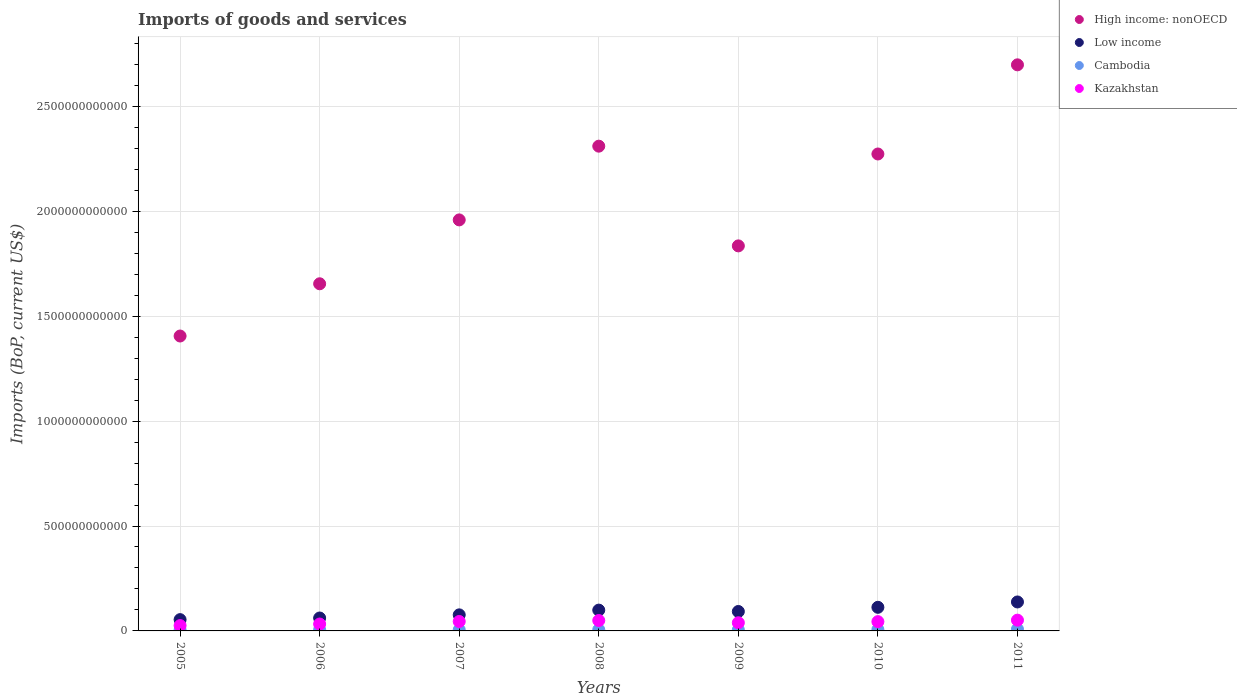What is the amount spent on imports in High income: nonOECD in 2009?
Provide a succinct answer. 1.83e+12. Across all years, what is the maximum amount spent on imports in Cambodia?
Give a very brief answer. 8.25e+09. Across all years, what is the minimum amount spent on imports in Cambodia?
Make the answer very short. 4.57e+09. What is the total amount spent on imports in Kazakhstan in the graph?
Provide a succinct answer. 2.87e+11. What is the difference between the amount spent on imports in Cambodia in 2008 and that in 2011?
Provide a succinct answer. -2.27e+09. What is the difference between the amount spent on imports in Kazakhstan in 2005 and the amount spent on imports in Cambodia in 2010?
Offer a terse response. 1.90e+1. What is the average amount spent on imports in Kazakhstan per year?
Keep it short and to the point. 4.11e+1. In the year 2007, what is the difference between the amount spent on imports in Kazakhstan and amount spent on imports in Low income?
Give a very brief answer. -3.16e+1. What is the ratio of the amount spent on imports in High income: nonOECD in 2006 to that in 2009?
Make the answer very short. 0.9. Is the difference between the amount spent on imports in Kazakhstan in 2007 and 2010 greater than the difference between the amount spent on imports in Low income in 2007 and 2010?
Offer a terse response. Yes. What is the difference between the highest and the second highest amount spent on imports in Low income?
Offer a terse response. 2.55e+1. What is the difference between the highest and the lowest amount spent on imports in Kazakhstan?
Ensure brevity in your answer.  2.59e+1. In how many years, is the amount spent on imports in High income: nonOECD greater than the average amount spent on imports in High income: nonOECD taken over all years?
Give a very brief answer. 3. Is the sum of the amount spent on imports in High income: nonOECD in 2007 and 2009 greater than the maximum amount spent on imports in Kazakhstan across all years?
Offer a very short reply. Yes. Is it the case that in every year, the sum of the amount spent on imports in Cambodia and amount spent on imports in Low income  is greater than the sum of amount spent on imports in Kazakhstan and amount spent on imports in High income: nonOECD?
Offer a very short reply. No. Is the amount spent on imports in High income: nonOECD strictly greater than the amount spent on imports in Cambodia over the years?
Offer a terse response. Yes. What is the difference between two consecutive major ticks on the Y-axis?
Provide a succinct answer. 5.00e+11. Does the graph contain grids?
Ensure brevity in your answer.  Yes. Where does the legend appear in the graph?
Provide a succinct answer. Top right. How many legend labels are there?
Your answer should be compact. 4. What is the title of the graph?
Your answer should be compact. Imports of goods and services. Does "Portugal" appear as one of the legend labels in the graph?
Your answer should be compact. No. What is the label or title of the Y-axis?
Your answer should be very brief. Imports (BoP, current US$). What is the Imports (BoP, current US$) in High income: nonOECD in 2005?
Provide a succinct answer. 1.41e+12. What is the Imports (BoP, current US$) of Low income in 2005?
Make the answer very short. 5.38e+1. What is the Imports (BoP, current US$) of Cambodia in 2005?
Provide a short and direct response. 4.57e+09. What is the Imports (BoP, current US$) in Kazakhstan in 2005?
Make the answer very short. 2.55e+1. What is the Imports (BoP, current US$) in High income: nonOECD in 2006?
Offer a very short reply. 1.65e+12. What is the Imports (BoP, current US$) of Low income in 2006?
Your answer should be compact. 6.15e+1. What is the Imports (BoP, current US$) of Cambodia in 2006?
Keep it short and to the point. 5.58e+09. What is the Imports (BoP, current US$) in Kazakhstan in 2006?
Your answer should be very brief. 3.29e+1. What is the Imports (BoP, current US$) in High income: nonOECD in 2007?
Offer a very short reply. 1.96e+12. What is the Imports (BoP, current US$) of Low income in 2007?
Your answer should be very brief. 7.65e+1. What is the Imports (BoP, current US$) of Cambodia in 2007?
Offer a very short reply. 5.34e+09. What is the Imports (BoP, current US$) in Kazakhstan in 2007?
Offer a very short reply. 4.50e+1. What is the Imports (BoP, current US$) in High income: nonOECD in 2008?
Provide a succinct answer. 2.31e+12. What is the Imports (BoP, current US$) in Low income in 2008?
Keep it short and to the point. 9.92e+1. What is the Imports (BoP, current US$) in Cambodia in 2008?
Your response must be concise. 5.98e+09. What is the Imports (BoP, current US$) in Kazakhstan in 2008?
Keep it short and to the point. 4.96e+1. What is the Imports (BoP, current US$) of High income: nonOECD in 2009?
Make the answer very short. 1.83e+12. What is the Imports (BoP, current US$) of Low income in 2009?
Provide a short and direct response. 9.26e+1. What is the Imports (BoP, current US$) of Cambodia in 2009?
Provide a short and direct response. 5.46e+09. What is the Imports (BoP, current US$) of Kazakhstan in 2009?
Provide a succinct answer. 3.90e+1. What is the Imports (BoP, current US$) of High income: nonOECD in 2010?
Provide a short and direct response. 2.27e+12. What is the Imports (BoP, current US$) in Low income in 2010?
Ensure brevity in your answer.  1.13e+11. What is the Imports (BoP, current US$) of Cambodia in 2010?
Make the answer very short. 6.47e+09. What is the Imports (BoP, current US$) of Kazakhstan in 2010?
Your answer should be very brief. 4.43e+1. What is the Imports (BoP, current US$) of High income: nonOECD in 2011?
Provide a short and direct response. 2.70e+12. What is the Imports (BoP, current US$) of Low income in 2011?
Make the answer very short. 1.38e+11. What is the Imports (BoP, current US$) in Cambodia in 2011?
Make the answer very short. 8.25e+09. What is the Imports (BoP, current US$) of Kazakhstan in 2011?
Provide a short and direct response. 5.13e+1. Across all years, what is the maximum Imports (BoP, current US$) of High income: nonOECD?
Ensure brevity in your answer.  2.70e+12. Across all years, what is the maximum Imports (BoP, current US$) in Low income?
Provide a short and direct response. 1.38e+11. Across all years, what is the maximum Imports (BoP, current US$) in Cambodia?
Offer a very short reply. 8.25e+09. Across all years, what is the maximum Imports (BoP, current US$) of Kazakhstan?
Offer a very short reply. 5.13e+1. Across all years, what is the minimum Imports (BoP, current US$) in High income: nonOECD?
Your answer should be compact. 1.41e+12. Across all years, what is the minimum Imports (BoP, current US$) of Low income?
Provide a short and direct response. 5.38e+1. Across all years, what is the minimum Imports (BoP, current US$) in Cambodia?
Your answer should be very brief. 4.57e+09. Across all years, what is the minimum Imports (BoP, current US$) in Kazakhstan?
Give a very brief answer. 2.55e+1. What is the total Imports (BoP, current US$) in High income: nonOECD in the graph?
Keep it short and to the point. 1.41e+13. What is the total Imports (BoP, current US$) in Low income in the graph?
Offer a very short reply. 6.34e+11. What is the total Imports (BoP, current US$) in Cambodia in the graph?
Offer a terse response. 4.16e+1. What is the total Imports (BoP, current US$) of Kazakhstan in the graph?
Provide a short and direct response. 2.87e+11. What is the difference between the Imports (BoP, current US$) of High income: nonOECD in 2005 and that in 2006?
Ensure brevity in your answer.  -2.49e+11. What is the difference between the Imports (BoP, current US$) in Low income in 2005 and that in 2006?
Your answer should be compact. -7.70e+09. What is the difference between the Imports (BoP, current US$) in Cambodia in 2005 and that in 2006?
Provide a short and direct response. -1.01e+09. What is the difference between the Imports (BoP, current US$) of Kazakhstan in 2005 and that in 2006?
Your response must be concise. -7.42e+09. What is the difference between the Imports (BoP, current US$) of High income: nonOECD in 2005 and that in 2007?
Make the answer very short. -5.53e+11. What is the difference between the Imports (BoP, current US$) in Low income in 2005 and that in 2007?
Ensure brevity in your answer.  -2.27e+1. What is the difference between the Imports (BoP, current US$) in Cambodia in 2005 and that in 2007?
Your answer should be compact. -7.61e+08. What is the difference between the Imports (BoP, current US$) of Kazakhstan in 2005 and that in 2007?
Your response must be concise. -1.95e+1. What is the difference between the Imports (BoP, current US$) of High income: nonOECD in 2005 and that in 2008?
Your answer should be very brief. -9.05e+11. What is the difference between the Imports (BoP, current US$) of Low income in 2005 and that in 2008?
Your answer should be compact. -4.53e+1. What is the difference between the Imports (BoP, current US$) in Cambodia in 2005 and that in 2008?
Your response must be concise. -1.40e+09. What is the difference between the Imports (BoP, current US$) of Kazakhstan in 2005 and that in 2008?
Make the answer very short. -2.41e+1. What is the difference between the Imports (BoP, current US$) of High income: nonOECD in 2005 and that in 2009?
Make the answer very short. -4.30e+11. What is the difference between the Imports (BoP, current US$) of Low income in 2005 and that in 2009?
Offer a terse response. -3.88e+1. What is the difference between the Imports (BoP, current US$) in Cambodia in 2005 and that in 2009?
Provide a succinct answer. -8.81e+08. What is the difference between the Imports (BoP, current US$) in Kazakhstan in 2005 and that in 2009?
Provide a short and direct response. -1.35e+1. What is the difference between the Imports (BoP, current US$) of High income: nonOECD in 2005 and that in 2010?
Keep it short and to the point. -8.68e+11. What is the difference between the Imports (BoP, current US$) in Low income in 2005 and that in 2010?
Offer a terse response. -5.87e+1. What is the difference between the Imports (BoP, current US$) of Cambodia in 2005 and that in 2010?
Your answer should be compact. -1.90e+09. What is the difference between the Imports (BoP, current US$) in Kazakhstan in 2005 and that in 2010?
Ensure brevity in your answer.  -1.88e+1. What is the difference between the Imports (BoP, current US$) of High income: nonOECD in 2005 and that in 2011?
Your answer should be very brief. -1.29e+12. What is the difference between the Imports (BoP, current US$) of Low income in 2005 and that in 2011?
Make the answer very short. -8.42e+1. What is the difference between the Imports (BoP, current US$) of Cambodia in 2005 and that in 2011?
Provide a succinct answer. -3.68e+09. What is the difference between the Imports (BoP, current US$) of Kazakhstan in 2005 and that in 2011?
Provide a succinct answer. -2.59e+1. What is the difference between the Imports (BoP, current US$) in High income: nonOECD in 2006 and that in 2007?
Your answer should be very brief. -3.04e+11. What is the difference between the Imports (BoP, current US$) in Low income in 2006 and that in 2007?
Your answer should be very brief. -1.50e+1. What is the difference between the Imports (BoP, current US$) in Cambodia in 2006 and that in 2007?
Your response must be concise. 2.46e+08. What is the difference between the Imports (BoP, current US$) of Kazakhstan in 2006 and that in 2007?
Provide a short and direct response. -1.21e+1. What is the difference between the Imports (BoP, current US$) in High income: nonOECD in 2006 and that in 2008?
Offer a very short reply. -6.56e+11. What is the difference between the Imports (BoP, current US$) in Low income in 2006 and that in 2008?
Give a very brief answer. -3.76e+1. What is the difference between the Imports (BoP, current US$) in Cambodia in 2006 and that in 2008?
Offer a very short reply. -3.96e+08. What is the difference between the Imports (BoP, current US$) in Kazakhstan in 2006 and that in 2008?
Provide a succinct answer. -1.67e+1. What is the difference between the Imports (BoP, current US$) in High income: nonOECD in 2006 and that in 2009?
Offer a very short reply. -1.81e+11. What is the difference between the Imports (BoP, current US$) of Low income in 2006 and that in 2009?
Ensure brevity in your answer.  -3.11e+1. What is the difference between the Imports (BoP, current US$) in Cambodia in 2006 and that in 2009?
Make the answer very short. 1.26e+08. What is the difference between the Imports (BoP, current US$) in Kazakhstan in 2006 and that in 2009?
Offer a very short reply. -6.12e+09. What is the difference between the Imports (BoP, current US$) of High income: nonOECD in 2006 and that in 2010?
Your answer should be compact. -6.19e+11. What is the difference between the Imports (BoP, current US$) in Low income in 2006 and that in 2010?
Provide a short and direct response. -5.10e+1. What is the difference between the Imports (BoP, current US$) in Cambodia in 2006 and that in 2010?
Keep it short and to the point. -8.91e+08. What is the difference between the Imports (BoP, current US$) in Kazakhstan in 2006 and that in 2010?
Keep it short and to the point. -1.14e+1. What is the difference between the Imports (BoP, current US$) in High income: nonOECD in 2006 and that in 2011?
Your response must be concise. -1.04e+12. What is the difference between the Imports (BoP, current US$) of Low income in 2006 and that in 2011?
Make the answer very short. -7.65e+1. What is the difference between the Imports (BoP, current US$) of Cambodia in 2006 and that in 2011?
Ensure brevity in your answer.  -2.67e+09. What is the difference between the Imports (BoP, current US$) in Kazakhstan in 2006 and that in 2011?
Give a very brief answer. -1.84e+1. What is the difference between the Imports (BoP, current US$) in High income: nonOECD in 2007 and that in 2008?
Your response must be concise. -3.51e+11. What is the difference between the Imports (BoP, current US$) of Low income in 2007 and that in 2008?
Provide a short and direct response. -2.26e+1. What is the difference between the Imports (BoP, current US$) in Cambodia in 2007 and that in 2008?
Your response must be concise. -6.42e+08. What is the difference between the Imports (BoP, current US$) of Kazakhstan in 2007 and that in 2008?
Provide a short and direct response. -4.58e+09. What is the difference between the Imports (BoP, current US$) in High income: nonOECD in 2007 and that in 2009?
Your answer should be compact. 1.24e+11. What is the difference between the Imports (BoP, current US$) of Low income in 2007 and that in 2009?
Your response must be concise. -1.61e+1. What is the difference between the Imports (BoP, current US$) in Cambodia in 2007 and that in 2009?
Keep it short and to the point. -1.20e+08. What is the difference between the Imports (BoP, current US$) of Kazakhstan in 2007 and that in 2009?
Your answer should be very brief. 5.99e+09. What is the difference between the Imports (BoP, current US$) of High income: nonOECD in 2007 and that in 2010?
Offer a very short reply. -3.14e+11. What is the difference between the Imports (BoP, current US$) of Low income in 2007 and that in 2010?
Your answer should be very brief. -3.60e+1. What is the difference between the Imports (BoP, current US$) of Cambodia in 2007 and that in 2010?
Provide a short and direct response. -1.14e+09. What is the difference between the Imports (BoP, current US$) in Kazakhstan in 2007 and that in 2010?
Your response must be concise. 7.30e+08. What is the difference between the Imports (BoP, current US$) in High income: nonOECD in 2007 and that in 2011?
Keep it short and to the point. -7.39e+11. What is the difference between the Imports (BoP, current US$) in Low income in 2007 and that in 2011?
Offer a very short reply. -6.15e+1. What is the difference between the Imports (BoP, current US$) in Cambodia in 2007 and that in 2011?
Give a very brief answer. -2.92e+09. What is the difference between the Imports (BoP, current US$) in Kazakhstan in 2007 and that in 2011?
Your answer should be compact. -6.33e+09. What is the difference between the Imports (BoP, current US$) of High income: nonOECD in 2008 and that in 2009?
Your answer should be very brief. 4.75e+11. What is the difference between the Imports (BoP, current US$) in Low income in 2008 and that in 2009?
Provide a succinct answer. 6.54e+09. What is the difference between the Imports (BoP, current US$) of Cambodia in 2008 and that in 2009?
Provide a short and direct response. 5.22e+08. What is the difference between the Imports (BoP, current US$) in Kazakhstan in 2008 and that in 2009?
Make the answer very short. 1.06e+1. What is the difference between the Imports (BoP, current US$) of High income: nonOECD in 2008 and that in 2010?
Provide a succinct answer. 3.72e+1. What is the difference between the Imports (BoP, current US$) of Low income in 2008 and that in 2010?
Give a very brief answer. -1.34e+1. What is the difference between the Imports (BoP, current US$) of Cambodia in 2008 and that in 2010?
Provide a short and direct response. -4.95e+08. What is the difference between the Imports (BoP, current US$) of Kazakhstan in 2008 and that in 2010?
Provide a succinct answer. 5.31e+09. What is the difference between the Imports (BoP, current US$) of High income: nonOECD in 2008 and that in 2011?
Your answer should be very brief. -3.88e+11. What is the difference between the Imports (BoP, current US$) in Low income in 2008 and that in 2011?
Provide a short and direct response. -3.89e+1. What is the difference between the Imports (BoP, current US$) in Cambodia in 2008 and that in 2011?
Provide a short and direct response. -2.27e+09. What is the difference between the Imports (BoP, current US$) in Kazakhstan in 2008 and that in 2011?
Offer a terse response. -1.75e+09. What is the difference between the Imports (BoP, current US$) in High income: nonOECD in 2009 and that in 2010?
Your response must be concise. -4.38e+11. What is the difference between the Imports (BoP, current US$) of Low income in 2009 and that in 2010?
Your answer should be compact. -1.99e+1. What is the difference between the Imports (BoP, current US$) in Cambodia in 2009 and that in 2010?
Provide a succinct answer. -1.02e+09. What is the difference between the Imports (BoP, current US$) in Kazakhstan in 2009 and that in 2010?
Your answer should be very brief. -5.26e+09. What is the difference between the Imports (BoP, current US$) of High income: nonOECD in 2009 and that in 2011?
Make the answer very short. -8.63e+11. What is the difference between the Imports (BoP, current US$) of Low income in 2009 and that in 2011?
Ensure brevity in your answer.  -4.54e+1. What is the difference between the Imports (BoP, current US$) in Cambodia in 2009 and that in 2011?
Your response must be concise. -2.80e+09. What is the difference between the Imports (BoP, current US$) in Kazakhstan in 2009 and that in 2011?
Ensure brevity in your answer.  -1.23e+1. What is the difference between the Imports (BoP, current US$) of High income: nonOECD in 2010 and that in 2011?
Keep it short and to the point. -4.25e+11. What is the difference between the Imports (BoP, current US$) of Low income in 2010 and that in 2011?
Your answer should be very brief. -2.55e+1. What is the difference between the Imports (BoP, current US$) of Cambodia in 2010 and that in 2011?
Make the answer very short. -1.78e+09. What is the difference between the Imports (BoP, current US$) of Kazakhstan in 2010 and that in 2011?
Ensure brevity in your answer.  -7.06e+09. What is the difference between the Imports (BoP, current US$) in High income: nonOECD in 2005 and the Imports (BoP, current US$) in Low income in 2006?
Your answer should be very brief. 1.34e+12. What is the difference between the Imports (BoP, current US$) of High income: nonOECD in 2005 and the Imports (BoP, current US$) of Cambodia in 2006?
Make the answer very short. 1.40e+12. What is the difference between the Imports (BoP, current US$) of High income: nonOECD in 2005 and the Imports (BoP, current US$) of Kazakhstan in 2006?
Keep it short and to the point. 1.37e+12. What is the difference between the Imports (BoP, current US$) in Low income in 2005 and the Imports (BoP, current US$) in Cambodia in 2006?
Give a very brief answer. 4.83e+1. What is the difference between the Imports (BoP, current US$) of Low income in 2005 and the Imports (BoP, current US$) of Kazakhstan in 2006?
Make the answer very short. 2.10e+1. What is the difference between the Imports (BoP, current US$) of Cambodia in 2005 and the Imports (BoP, current US$) of Kazakhstan in 2006?
Ensure brevity in your answer.  -2.83e+1. What is the difference between the Imports (BoP, current US$) of High income: nonOECD in 2005 and the Imports (BoP, current US$) of Low income in 2007?
Ensure brevity in your answer.  1.33e+12. What is the difference between the Imports (BoP, current US$) in High income: nonOECD in 2005 and the Imports (BoP, current US$) in Cambodia in 2007?
Offer a terse response. 1.40e+12. What is the difference between the Imports (BoP, current US$) in High income: nonOECD in 2005 and the Imports (BoP, current US$) in Kazakhstan in 2007?
Your answer should be compact. 1.36e+12. What is the difference between the Imports (BoP, current US$) in Low income in 2005 and the Imports (BoP, current US$) in Cambodia in 2007?
Your answer should be compact. 4.85e+1. What is the difference between the Imports (BoP, current US$) in Low income in 2005 and the Imports (BoP, current US$) in Kazakhstan in 2007?
Offer a terse response. 8.85e+09. What is the difference between the Imports (BoP, current US$) in Cambodia in 2005 and the Imports (BoP, current US$) in Kazakhstan in 2007?
Provide a succinct answer. -4.04e+1. What is the difference between the Imports (BoP, current US$) in High income: nonOECD in 2005 and the Imports (BoP, current US$) in Low income in 2008?
Your response must be concise. 1.31e+12. What is the difference between the Imports (BoP, current US$) in High income: nonOECD in 2005 and the Imports (BoP, current US$) in Cambodia in 2008?
Your answer should be very brief. 1.40e+12. What is the difference between the Imports (BoP, current US$) in High income: nonOECD in 2005 and the Imports (BoP, current US$) in Kazakhstan in 2008?
Your response must be concise. 1.36e+12. What is the difference between the Imports (BoP, current US$) of Low income in 2005 and the Imports (BoP, current US$) of Cambodia in 2008?
Keep it short and to the point. 4.79e+1. What is the difference between the Imports (BoP, current US$) of Low income in 2005 and the Imports (BoP, current US$) of Kazakhstan in 2008?
Provide a succinct answer. 4.27e+09. What is the difference between the Imports (BoP, current US$) of Cambodia in 2005 and the Imports (BoP, current US$) of Kazakhstan in 2008?
Ensure brevity in your answer.  -4.50e+1. What is the difference between the Imports (BoP, current US$) of High income: nonOECD in 2005 and the Imports (BoP, current US$) of Low income in 2009?
Ensure brevity in your answer.  1.31e+12. What is the difference between the Imports (BoP, current US$) of High income: nonOECD in 2005 and the Imports (BoP, current US$) of Cambodia in 2009?
Give a very brief answer. 1.40e+12. What is the difference between the Imports (BoP, current US$) of High income: nonOECD in 2005 and the Imports (BoP, current US$) of Kazakhstan in 2009?
Offer a terse response. 1.37e+12. What is the difference between the Imports (BoP, current US$) of Low income in 2005 and the Imports (BoP, current US$) of Cambodia in 2009?
Give a very brief answer. 4.84e+1. What is the difference between the Imports (BoP, current US$) in Low income in 2005 and the Imports (BoP, current US$) in Kazakhstan in 2009?
Your answer should be compact. 1.48e+1. What is the difference between the Imports (BoP, current US$) in Cambodia in 2005 and the Imports (BoP, current US$) in Kazakhstan in 2009?
Keep it short and to the point. -3.44e+1. What is the difference between the Imports (BoP, current US$) in High income: nonOECD in 2005 and the Imports (BoP, current US$) in Low income in 2010?
Ensure brevity in your answer.  1.29e+12. What is the difference between the Imports (BoP, current US$) of High income: nonOECD in 2005 and the Imports (BoP, current US$) of Cambodia in 2010?
Your answer should be compact. 1.40e+12. What is the difference between the Imports (BoP, current US$) in High income: nonOECD in 2005 and the Imports (BoP, current US$) in Kazakhstan in 2010?
Make the answer very short. 1.36e+12. What is the difference between the Imports (BoP, current US$) in Low income in 2005 and the Imports (BoP, current US$) in Cambodia in 2010?
Your answer should be very brief. 4.74e+1. What is the difference between the Imports (BoP, current US$) of Low income in 2005 and the Imports (BoP, current US$) of Kazakhstan in 2010?
Offer a very short reply. 9.58e+09. What is the difference between the Imports (BoP, current US$) of Cambodia in 2005 and the Imports (BoP, current US$) of Kazakhstan in 2010?
Give a very brief answer. -3.97e+1. What is the difference between the Imports (BoP, current US$) in High income: nonOECD in 2005 and the Imports (BoP, current US$) in Low income in 2011?
Your answer should be compact. 1.27e+12. What is the difference between the Imports (BoP, current US$) of High income: nonOECD in 2005 and the Imports (BoP, current US$) of Cambodia in 2011?
Keep it short and to the point. 1.40e+12. What is the difference between the Imports (BoP, current US$) of High income: nonOECD in 2005 and the Imports (BoP, current US$) of Kazakhstan in 2011?
Your answer should be compact. 1.35e+12. What is the difference between the Imports (BoP, current US$) in Low income in 2005 and the Imports (BoP, current US$) in Cambodia in 2011?
Offer a terse response. 4.56e+1. What is the difference between the Imports (BoP, current US$) of Low income in 2005 and the Imports (BoP, current US$) of Kazakhstan in 2011?
Your answer should be very brief. 2.52e+09. What is the difference between the Imports (BoP, current US$) of Cambodia in 2005 and the Imports (BoP, current US$) of Kazakhstan in 2011?
Give a very brief answer. -4.67e+1. What is the difference between the Imports (BoP, current US$) in High income: nonOECD in 2006 and the Imports (BoP, current US$) in Low income in 2007?
Your answer should be compact. 1.58e+12. What is the difference between the Imports (BoP, current US$) in High income: nonOECD in 2006 and the Imports (BoP, current US$) in Cambodia in 2007?
Give a very brief answer. 1.65e+12. What is the difference between the Imports (BoP, current US$) in High income: nonOECD in 2006 and the Imports (BoP, current US$) in Kazakhstan in 2007?
Your answer should be compact. 1.61e+12. What is the difference between the Imports (BoP, current US$) in Low income in 2006 and the Imports (BoP, current US$) in Cambodia in 2007?
Make the answer very short. 5.62e+1. What is the difference between the Imports (BoP, current US$) in Low income in 2006 and the Imports (BoP, current US$) in Kazakhstan in 2007?
Provide a succinct answer. 1.66e+1. What is the difference between the Imports (BoP, current US$) of Cambodia in 2006 and the Imports (BoP, current US$) of Kazakhstan in 2007?
Your answer should be very brief. -3.94e+1. What is the difference between the Imports (BoP, current US$) of High income: nonOECD in 2006 and the Imports (BoP, current US$) of Low income in 2008?
Offer a very short reply. 1.56e+12. What is the difference between the Imports (BoP, current US$) in High income: nonOECD in 2006 and the Imports (BoP, current US$) in Cambodia in 2008?
Offer a terse response. 1.65e+12. What is the difference between the Imports (BoP, current US$) of High income: nonOECD in 2006 and the Imports (BoP, current US$) of Kazakhstan in 2008?
Your answer should be very brief. 1.60e+12. What is the difference between the Imports (BoP, current US$) of Low income in 2006 and the Imports (BoP, current US$) of Cambodia in 2008?
Your answer should be compact. 5.56e+1. What is the difference between the Imports (BoP, current US$) of Low income in 2006 and the Imports (BoP, current US$) of Kazakhstan in 2008?
Give a very brief answer. 1.20e+1. What is the difference between the Imports (BoP, current US$) of Cambodia in 2006 and the Imports (BoP, current US$) of Kazakhstan in 2008?
Keep it short and to the point. -4.40e+1. What is the difference between the Imports (BoP, current US$) in High income: nonOECD in 2006 and the Imports (BoP, current US$) in Low income in 2009?
Give a very brief answer. 1.56e+12. What is the difference between the Imports (BoP, current US$) in High income: nonOECD in 2006 and the Imports (BoP, current US$) in Cambodia in 2009?
Your answer should be compact. 1.65e+12. What is the difference between the Imports (BoP, current US$) of High income: nonOECD in 2006 and the Imports (BoP, current US$) of Kazakhstan in 2009?
Ensure brevity in your answer.  1.62e+12. What is the difference between the Imports (BoP, current US$) of Low income in 2006 and the Imports (BoP, current US$) of Cambodia in 2009?
Your answer should be very brief. 5.61e+1. What is the difference between the Imports (BoP, current US$) of Low income in 2006 and the Imports (BoP, current US$) of Kazakhstan in 2009?
Offer a very short reply. 2.25e+1. What is the difference between the Imports (BoP, current US$) in Cambodia in 2006 and the Imports (BoP, current US$) in Kazakhstan in 2009?
Offer a terse response. -3.34e+1. What is the difference between the Imports (BoP, current US$) of High income: nonOECD in 2006 and the Imports (BoP, current US$) of Low income in 2010?
Provide a succinct answer. 1.54e+12. What is the difference between the Imports (BoP, current US$) of High income: nonOECD in 2006 and the Imports (BoP, current US$) of Cambodia in 2010?
Provide a succinct answer. 1.65e+12. What is the difference between the Imports (BoP, current US$) of High income: nonOECD in 2006 and the Imports (BoP, current US$) of Kazakhstan in 2010?
Offer a very short reply. 1.61e+12. What is the difference between the Imports (BoP, current US$) in Low income in 2006 and the Imports (BoP, current US$) in Cambodia in 2010?
Make the answer very short. 5.51e+1. What is the difference between the Imports (BoP, current US$) of Low income in 2006 and the Imports (BoP, current US$) of Kazakhstan in 2010?
Your response must be concise. 1.73e+1. What is the difference between the Imports (BoP, current US$) of Cambodia in 2006 and the Imports (BoP, current US$) of Kazakhstan in 2010?
Offer a terse response. -3.87e+1. What is the difference between the Imports (BoP, current US$) in High income: nonOECD in 2006 and the Imports (BoP, current US$) in Low income in 2011?
Offer a very short reply. 1.52e+12. What is the difference between the Imports (BoP, current US$) of High income: nonOECD in 2006 and the Imports (BoP, current US$) of Cambodia in 2011?
Provide a short and direct response. 1.65e+12. What is the difference between the Imports (BoP, current US$) of High income: nonOECD in 2006 and the Imports (BoP, current US$) of Kazakhstan in 2011?
Offer a terse response. 1.60e+12. What is the difference between the Imports (BoP, current US$) in Low income in 2006 and the Imports (BoP, current US$) in Cambodia in 2011?
Make the answer very short. 5.33e+1. What is the difference between the Imports (BoP, current US$) in Low income in 2006 and the Imports (BoP, current US$) in Kazakhstan in 2011?
Offer a terse response. 1.02e+1. What is the difference between the Imports (BoP, current US$) in Cambodia in 2006 and the Imports (BoP, current US$) in Kazakhstan in 2011?
Give a very brief answer. -4.57e+1. What is the difference between the Imports (BoP, current US$) in High income: nonOECD in 2007 and the Imports (BoP, current US$) in Low income in 2008?
Your answer should be compact. 1.86e+12. What is the difference between the Imports (BoP, current US$) in High income: nonOECD in 2007 and the Imports (BoP, current US$) in Cambodia in 2008?
Your answer should be very brief. 1.95e+12. What is the difference between the Imports (BoP, current US$) in High income: nonOECD in 2007 and the Imports (BoP, current US$) in Kazakhstan in 2008?
Your answer should be very brief. 1.91e+12. What is the difference between the Imports (BoP, current US$) of Low income in 2007 and the Imports (BoP, current US$) of Cambodia in 2008?
Provide a short and direct response. 7.06e+1. What is the difference between the Imports (BoP, current US$) of Low income in 2007 and the Imports (BoP, current US$) of Kazakhstan in 2008?
Ensure brevity in your answer.  2.70e+1. What is the difference between the Imports (BoP, current US$) of Cambodia in 2007 and the Imports (BoP, current US$) of Kazakhstan in 2008?
Make the answer very short. -4.42e+1. What is the difference between the Imports (BoP, current US$) in High income: nonOECD in 2007 and the Imports (BoP, current US$) in Low income in 2009?
Your answer should be compact. 1.87e+12. What is the difference between the Imports (BoP, current US$) of High income: nonOECD in 2007 and the Imports (BoP, current US$) of Cambodia in 2009?
Your answer should be very brief. 1.95e+12. What is the difference between the Imports (BoP, current US$) of High income: nonOECD in 2007 and the Imports (BoP, current US$) of Kazakhstan in 2009?
Ensure brevity in your answer.  1.92e+12. What is the difference between the Imports (BoP, current US$) of Low income in 2007 and the Imports (BoP, current US$) of Cambodia in 2009?
Your response must be concise. 7.11e+1. What is the difference between the Imports (BoP, current US$) of Low income in 2007 and the Imports (BoP, current US$) of Kazakhstan in 2009?
Keep it short and to the point. 3.75e+1. What is the difference between the Imports (BoP, current US$) in Cambodia in 2007 and the Imports (BoP, current US$) in Kazakhstan in 2009?
Give a very brief answer. -3.37e+1. What is the difference between the Imports (BoP, current US$) in High income: nonOECD in 2007 and the Imports (BoP, current US$) in Low income in 2010?
Ensure brevity in your answer.  1.85e+12. What is the difference between the Imports (BoP, current US$) of High income: nonOECD in 2007 and the Imports (BoP, current US$) of Cambodia in 2010?
Give a very brief answer. 1.95e+12. What is the difference between the Imports (BoP, current US$) of High income: nonOECD in 2007 and the Imports (BoP, current US$) of Kazakhstan in 2010?
Give a very brief answer. 1.91e+12. What is the difference between the Imports (BoP, current US$) of Low income in 2007 and the Imports (BoP, current US$) of Cambodia in 2010?
Offer a terse response. 7.01e+1. What is the difference between the Imports (BoP, current US$) of Low income in 2007 and the Imports (BoP, current US$) of Kazakhstan in 2010?
Offer a terse response. 3.23e+1. What is the difference between the Imports (BoP, current US$) of Cambodia in 2007 and the Imports (BoP, current US$) of Kazakhstan in 2010?
Provide a succinct answer. -3.89e+1. What is the difference between the Imports (BoP, current US$) of High income: nonOECD in 2007 and the Imports (BoP, current US$) of Low income in 2011?
Make the answer very short. 1.82e+12. What is the difference between the Imports (BoP, current US$) in High income: nonOECD in 2007 and the Imports (BoP, current US$) in Cambodia in 2011?
Keep it short and to the point. 1.95e+12. What is the difference between the Imports (BoP, current US$) of High income: nonOECD in 2007 and the Imports (BoP, current US$) of Kazakhstan in 2011?
Make the answer very short. 1.91e+12. What is the difference between the Imports (BoP, current US$) of Low income in 2007 and the Imports (BoP, current US$) of Cambodia in 2011?
Your answer should be very brief. 6.83e+1. What is the difference between the Imports (BoP, current US$) of Low income in 2007 and the Imports (BoP, current US$) of Kazakhstan in 2011?
Provide a short and direct response. 2.52e+1. What is the difference between the Imports (BoP, current US$) in Cambodia in 2007 and the Imports (BoP, current US$) in Kazakhstan in 2011?
Your answer should be very brief. -4.60e+1. What is the difference between the Imports (BoP, current US$) in High income: nonOECD in 2008 and the Imports (BoP, current US$) in Low income in 2009?
Keep it short and to the point. 2.22e+12. What is the difference between the Imports (BoP, current US$) in High income: nonOECD in 2008 and the Imports (BoP, current US$) in Cambodia in 2009?
Your response must be concise. 2.30e+12. What is the difference between the Imports (BoP, current US$) of High income: nonOECD in 2008 and the Imports (BoP, current US$) of Kazakhstan in 2009?
Provide a short and direct response. 2.27e+12. What is the difference between the Imports (BoP, current US$) of Low income in 2008 and the Imports (BoP, current US$) of Cambodia in 2009?
Make the answer very short. 9.37e+1. What is the difference between the Imports (BoP, current US$) of Low income in 2008 and the Imports (BoP, current US$) of Kazakhstan in 2009?
Offer a terse response. 6.02e+1. What is the difference between the Imports (BoP, current US$) in Cambodia in 2008 and the Imports (BoP, current US$) in Kazakhstan in 2009?
Your answer should be compact. -3.30e+1. What is the difference between the Imports (BoP, current US$) of High income: nonOECD in 2008 and the Imports (BoP, current US$) of Low income in 2010?
Keep it short and to the point. 2.20e+12. What is the difference between the Imports (BoP, current US$) of High income: nonOECD in 2008 and the Imports (BoP, current US$) of Cambodia in 2010?
Offer a terse response. 2.30e+12. What is the difference between the Imports (BoP, current US$) in High income: nonOECD in 2008 and the Imports (BoP, current US$) in Kazakhstan in 2010?
Keep it short and to the point. 2.27e+12. What is the difference between the Imports (BoP, current US$) of Low income in 2008 and the Imports (BoP, current US$) of Cambodia in 2010?
Keep it short and to the point. 9.27e+1. What is the difference between the Imports (BoP, current US$) of Low income in 2008 and the Imports (BoP, current US$) of Kazakhstan in 2010?
Your answer should be compact. 5.49e+1. What is the difference between the Imports (BoP, current US$) of Cambodia in 2008 and the Imports (BoP, current US$) of Kazakhstan in 2010?
Give a very brief answer. -3.83e+1. What is the difference between the Imports (BoP, current US$) in High income: nonOECD in 2008 and the Imports (BoP, current US$) in Low income in 2011?
Provide a short and direct response. 2.17e+12. What is the difference between the Imports (BoP, current US$) of High income: nonOECD in 2008 and the Imports (BoP, current US$) of Cambodia in 2011?
Ensure brevity in your answer.  2.30e+12. What is the difference between the Imports (BoP, current US$) of High income: nonOECD in 2008 and the Imports (BoP, current US$) of Kazakhstan in 2011?
Your response must be concise. 2.26e+12. What is the difference between the Imports (BoP, current US$) of Low income in 2008 and the Imports (BoP, current US$) of Cambodia in 2011?
Your response must be concise. 9.09e+1. What is the difference between the Imports (BoP, current US$) in Low income in 2008 and the Imports (BoP, current US$) in Kazakhstan in 2011?
Provide a short and direct response. 4.79e+1. What is the difference between the Imports (BoP, current US$) of Cambodia in 2008 and the Imports (BoP, current US$) of Kazakhstan in 2011?
Offer a terse response. -4.53e+1. What is the difference between the Imports (BoP, current US$) of High income: nonOECD in 2009 and the Imports (BoP, current US$) of Low income in 2010?
Provide a short and direct response. 1.72e+12. What is the difference between the Imports (BoP, current US$) in High income: nonOECD in 2009 and the Imports (BoP, current US$) in Cambodia in 2010?
Provide a short and direct response. 1.83e+12. What is the difference between the Imports (BoP, current US$) of High income: nonOECD in 2009 and the Imports (BoP, current US$) of Kazakhstan in 2010?
Offer a very short reply. 1.79e+12. What is the difference between the Imports (BoP, current US$) of Low income in 2009 and the Imports (BoP, current US$) of Cambodia in 2010?
Keep it short and to the point. 8.62e+1. What is the difference between the Imports (BoP, current US$) of Low income in 2009 and the Imports (BoP, current US$) of Kazakhstan in 2010?
Offer a very short reply. 4.84e+1. What is the difference between the Imports (BoP, current US$) in Cambodia in 2009 and the Imports (BoP, current US$) in Kazakhstan in 2010?
Offer a very short reply. -3.88e+1. What is the difference between the Imports (BoP, current US$) in High income: nonOECD in 2009 and the Imports (BoP, current US$) in Low income in 2011?
Provide a succinct answer. 1.70e+12. What is the difference between the Imports (BoP, current US$) of High income: nonOECD in 2009 and the Imports (BoP, current US$) of Cambodia in 2011?
Provide a succinct answer. 1.83e+12. What is the difference between the Imports (BoP, current US$) of High income: nonOECD in 2009 and the Imports (BoP, current US$) of Kazakhstan in 2011?
Your answer should be very brief. 1.78e+12. What is the difference between the Imports (BoP, current US$) in Low income in 2009 and the Imports (BoP, current US$) in Cambodia in 2011?
Give a very brief answer. 8.44e+1. What is the difference between the Imports (BoP, current US$) in Low income in 2009 and the Imports (BoP, current US$) in Kazakhstan in 2011?
Offer a very short reply. 4.13e+1. What is the difference between the Imports (BoP, current US$) of Cambodia in 2009 and the Imports (BoP, current US$) of Kazakhstan in 2011?
Make the answer very short. -4.59e+1. What is the difference between the Imports (BoP, current US$) in High income: nonOECD in 2010 and the Imports (BoP, current US$) in Low income in 2011?
Offer a terse response. 2.13e+12. What is the difference between the Imports (BoP, current US$) of High income: nonOECD in 2010 and the Imports (BoP, current US$) of Cambodia in 2011?
Offer a terse response. 2.26e+12. What is the difference between the Imports (BoP, current US$) of High income: nonOECD in 2010 and the Imports (BoP, current US$) of Kazakhstan in 2011?
Provide a short and direct response. 2.22e+12. What is the difference between the Imports (BoP, current US$) of Low income in 2010 and the Imports (BoP, current US$) of Cambodia in 2011?
Offer a terse response. 1.04e+11. What is the difference between the Imports (BoP, current US$) of Low income in 2010 and the Imports (BoP, current US$) of Kazakhstan in 2011?
Your response must be concise. 6.12e+1. What is the difference between the Imports (BoP, current US$) in Cambodia in 2010 and the Imports (BoP, current US$) in Kazakhstan in 2011?
Make the answer very short. -4.49e+1. What is the average Imports (BoP, current US$) of High income: nonOECD per year?
Your response must be concise. 2.02e+12. What is the average Imports (BoP, current US$) of Low income per year?
Provide a short and direct response. 9.06e+1. What is the average Imports (BoP, current US$) of Cambodia per year?
Provide a short and direct response. 5.95e+09. What is the average Imports (BoP, current US$) of Kazakhstan per year?
Provide a short and direct response. 4.11e+1. In the year 2005, what is the difference between the Imports (BoP, current US$) in High income: nonOECD and Imports (BoP, current US$) in Low income?
Your answer should be compact. 1.35e+12. In the year 2005, what is the difference between the Imports (BoP, current US$) of High income: nonOECD and Imports (BoP, current US$) of Cambodia?
Offer a terse response. 1.40e+12. In the year 2005, what is the difference between the Imports (BoP, current US$) in High income: nonOECD and Imports (BoP, current US$) in Kazakhstan?
Provide a short and direct response. 1.38e+12. In the year 2005, what is the difference between the Imports (BoP, current US$) of Low income and Imports (BoP, current US$) of Cambodia?
Offer a very short reply. 4.93e+1. In the year 2005, what is the difference between the Imports (BoP, current US$) of Low income and Imports (BoP, current US$) of Kazakhstan?
Offer a very short reply. 2.84e+1. In the year 2005, what is the difference between the Imports (BoP, current US$) in Cambodia and Imports (BoP, current US$) in Kazakhstan?
Offer a terse response. -2.09e+1. In the year 2006, what is the difference between the Imports (BoP, current US$) of High income: nonOECD and Imports (BoP, current US$) of Low income?
Your answer should be very brief. 1.59e+12. In the year 2006, what is the difference between the Imports (BoP, current US$) in High income: nonOECD and Imports (BoP, current US$) in Cambodia?
Your response must be concise. 1.65e+12. In the year 2006, what is the difference between the Imports (BoP, current US$) in High income: nonOECD and Imports (BoP, current US$) in Kazakhstan?
Provide a succinct answer. 1.62e+12. In the year 2006, what is the difference between the Imports (BoP, current US$) of Low income and Imports (BoP, current US$) of Cambodia?
Your answer should be very brief. 5.60e+1. In the year 2006, what is the difference between the Imports (BoP, current US$) in Low income and Imports (BoP, current US$) in Kazakhstan?
Offer a terse response. 2.87e+1. In the year 2006, what is the difference between the Imports (BoP, current US$) in Cambodia and Imports (BoP, current US$) in Kazakhstan?
Provide a short and direct response. -2.73e+1. In the year 2007, what is the difference between the Imports (BoP, current US$) in High income: nonOECD and Imports (BoP, current US$) in Low income?
Offer a very short reply. 1.88e+12. In the year 2007, what is the difference between the Imports (BoP, current US$) of High income: nonOECD and Imports (BoP, current US$) of Cambodia?
Your answer should be very brief. 1.95e+12. In the year 2007, what is the difference between the Imports (BoP, current US$) in High income: nonOECD and Imports (BoP, current US$) in Kazakhstan?
Provide a short and direct response. 1.91e+12. In the year 2007, what is the difference between the Imports (BoP, current US$) in Low income and Imports (BoP, current US$) in Cambodia?
Your answer should be very brief. 7.12e+1. In the year 2007, what is the difference between the Imports (BoP, current US$) of Low income and Imports (BoP, current US$) of Kazakhstan?
Provide a short and direct response. 3.16e+1. In the year 2007, what is the difference between the Imports (BoP, current US$) in Cambodia and Imports (BoP, current US$) in Kazakhstan?
Give a very brief answer. -3.97e+1. In the year 2008, what is the difference between the Imports (BoP, current US$) in High income: nonOECD and Imports (BoP, current US$) in Low income?
Offer a terse response. 2.21e+12. In the year 2008, what is the difference between the Imports (BoP, current US$) of High income: nonOECD and Imports (BoP, current US$) of Cambodia?
Provide a succinct answer. 2.30e+12. In the year 2008, what is the difference between the Imports (BoP, current US$) of High income: nonOECD and Imports (BoP, current US$) of Kazakhstan?
Your answer should be compact. 2.26e+12. In the year 2008, what is the difference between the Imports (BoP, current US$) in Low income and Imports (BoP, current US$) in Cambodia?
Give a very brief answer. 9.32e+1. In the year 2008, what is the difference between the Imports (BoP, current US$) in Low income and Imports (BoP, current US$) in Kazakhstan?
Offer a very short reply. 4.96e+1. In the year 2008, what is the difference between the Imports (BoP, current US$) of Cambodia and Imports (BoP, current US$) of Kazakhstan?
Your answer should be compact. -4.36e+1. In the year 2009, what is the difference between the Imports (BoP, current US$) in High income: nonOECD and Imports (BoP, current US$) in Low income?
Provide a succinct answer. 1.74e+12. In the year 2009, what is the difference between the Imports (BoP, current US$) in High income: nonOECD and Imports (BoP, current US$) in Cambodia?
Your response must be concise. 1.83e+12. In the year 2009, what is the difference between the Imports (BoP, current US$) in High income: nonOECD and Imports (BoP, current US$) in Kazakhstan?
Ensure brevity in your answer.  1.80e+12. In the year 2009, what is the difference between the Imports (BoP, current US$) in Low income and Imports (BoP, current US$) in Cambodia?
Ensure brevity in your answer.  8.72e+1. In the year 2009, what is the difference between the Imports (BoP, current US$) of Low income and Imports (BoP, current US$) of Kazakhstan?
Offer a very short reply. 5.36e+1. In the year 2009, what is the difference between the Imports (BoP, current US$) of Cambodia and Imports (BoP, current US$) of Kazakhstan?
Ensure brevity in your answer.  -3.35e+1. In the year 2010, what is the difference between the Imports (BoP, current US$) of High income: nonOECD and Imports (BoP, current US$) of Low income?
Your answer should be very brief. 2.16e+12. In the year 2010, what is the difference between the Imports (BoP, current US$) in High income: nonOECD and Imports (BoP, current US$) in Cambodia?
Offer a terse response. 2.27e+12. In the year 2010, what is the difference between the Imports (BoP, current US$) in High income: nonOECD and Imports (BoP, current US$) in Kazakhstan?
Your answer should be compact. 2.23e+12. In the year 2010, what is the difference between the Imports (BoP, current US$) in Low income and Imports (BoP, current US$) in Cambodia?
Keep it short and to the point. 1.06e+11. In the year 2010, what is the difference between the Imports (BoP, current US$) in Low income and Imports (BoP, current US$) in Kazakhstan?
Ensure brevity in your answer.  6.83e+1. In the year 2010, what is the difference between the Imports (BoP, current US$) of Cambodia and Imports (BoP, current US$) of Kazakhstan?
Make the answer very short. -3.78e+1. In the year 2011, what is the difference between the Imports (BoP, current US$) of High income: nonOECD and Imports (BoP, current US$) of Low income?
Your answer should be compact. 2.56e+12. In the year 2011, what is the difference between the Imports (BoP, current US$) in High income: nonOECD and Imports (BoP, current US$) in Cambodia?
Your answer should be compact. 2.69e+12. In the year 2011, what is the difference between the Imports (BoP, current US$) of High income: nonOECD and Imports (BoP, current US$) of Kazakhstan?
Ensure brevity in your answer.  2.65e+12. In the year 2011, what is the difference between the Imports (BoP, current US$) in Low income and Imports (BoP, current US$) in Cambodia?
Your response must be concise. 1.30e+11. In the year 2011, what is the difference between the Imports (BoP, current US$) in Low income and Imports (BoP, current US$) in Kazakhstan?
Offer a terse response. 8.67e+1. In the year 2011, what is the difference between the Imports (BoP, current US$) in Cambodia and Imports (BoP, current US$) in Kazakhstan?
Your response must be concise. -4.31e+1. What is the ratio of the Imports (BoP, current US$) in High income: nonOECD in 2005 to that in 2006?
Your response must be concise. 0.85. What is the ratio of the Imports (BoP, current US$) in Low income in 2005 to that in 2006?
Provide a succinct answer. 0.87. What is the ratio of the Imports (BoP, current US$) in Cambodia in 2005 to that in 2006?
Keep it short and to the point. 0.82. What is the ratio of the Imports (BoP, current US$) of Kazakhstan in 2005 to that in 2006?
Keep it short and to the point. 0.77. What is the ratio of the Imports (BoP, current US$) in High income: nonOECD in 2005 to that in 2007?
Offer a very short reply. 0.72. What is the ratio of the Imports (BoP, current US$) of Low income in 2005 to that in 2007?
Provide a short and direct response. 0.7. What is the ratio of the Imports (BoP, current US$) of Cambodia in 2005 to that in 2007?
Offer a terse response. 0.86. What is the ratio of the Imports (BoP, current US$) of Kazakhstan in 2005 to that in 2007?
Offer a terse response. 0.57. What is the ratio of the Imports (BoP, current US$) of High income: nonOECD in 2005 to that in 2008?
Your answer should be very brief. 0.61. What is the ratio of the Imports (BoP, current US$) in Low income in 2005 to that in 2008?
Provide a short and direct response. 0.54. What is the ratio of the Imports (BoP, current US$) in Cambodia in 2005 to that in 2008?
Give a very brief answer. 0.77. What is the ratio of the Imports (BoP, current US$) of Kazakhstan in 2005 to that in 2008?
Offer a terse response. 0.51. What is the ratio of the Imports (BoP, current US$) of High income: nonOECD in 2005 to that in 2009?
Offer a very short reply. 0.77. What is the ratio of the Imports (BoP, current US$) of Low income in 2005 to that in 2009?
Make the answer very short. 0.58. What is the ratio of the Imports (BoP, current US$) of Cambodia in 2005 to that in 2009?
Provide a succinct answer. 0.84. What is the ratio of the Imports (BoP, current US$) in Kazakhstan in 2005 to that in 2009?
Make the answer very short. 0.65. What is the ratio of the Imports (BoP, current US$) in High income: nonOECD in 2005 to that in 2010?
Make the answer very short. 0.62. What is the ratio of the Imports (BoP, current US$) in Low income in 2005 to that in 2010?
Offer a very short reply. 0.48. What is the ratio of the Imports (BoP, current US$) in Cambodia in 2005 to that in 2010?
Your answer should be very brief. 0.71. What is the ratio of the Imports (BoP, current US$) in Kazakhstan in 2005 to that in 2010?
Your response must be concise. 0.58. What is the ratio of the Imports (BoP, current US$) of High income: nonOECD in 2005 to that in 2011?
Give a very brief answer. 0.52. What is the ratio of the Imports (BoP, current US$) in Low income in 2005 to that in 2011?
Ensure brevity in your answer.  0.39. What is the ratio of the Imports (BoP, current US$) in Cambodia in 2005 to that in 2011?
Keep it short and to the point. 0.55. What is the ratio of the Imports (BoP, current US$) of Kazakhstan in 2005 to that in 2011?
Keep it short and to the point. 0.5. What is the ratio of the Imports (BoP, current US$) of High income: nonOECD in 2006 to that in 2007?
Ensure brevity in your answer.  0.84. What is the ratio of the Imports (BoP, current US$) in Low income in 2006 to that in 2007?
Your response must be concise. 0.8. What is the ratio of the Imports (BoP, current US$) in Cambodia in 2006 to that in 2007?
Provide a short and direct response. 1.05. What is the ratio of the Imports (BoP, current US$) in Kazakhstan in 2006 to that in 2007?
Your answer should be compact. 0.73. What is the ratio of the Imports (BoP, current US$) of High income: nonOECD in 2006 to that in 2008?
Provide a succinct answer. 0.72. What is the ratio of the Imports (BoP, current US$) of Low income in 2006 to that in 2008?
Your response must be concise. 0.62. What is the ratio of the Imports (BoP, current US$) in Cambodia in 2006 to that in 2008?
Your answer should be compact. 0.93. What is the ratio of the Imports (BoP, current US$) in Kazakhstan in 2006 to that in 2008?
Give a very brief answer. 0.66. What is the ratio of the Imports (BoP, current US$) of High income: nonOECD in 2006 to that in 2009?
Offer a very short reply. 0.9. What is the ratio of the Imports (BoP, current US$) in Low income in 2006 to that in 2009?
Your response must be concise. 0.66. What is the ratio of the Imports (BoP, current US$) in Cambodia in 2006 to that in 2009?
Keep it short and to the point. 1.02. What is the ratio of the Imports (BoP, current US$) in Kazakhstan in 2006 to that in 2009?
Your response must be concise. 0.84. What is the ratio of the Imports (BoP, current US$) of High income: nonOECD in 2006 to that in 2010?
Your answer should be compact. 0.73. What is the ratio of the Imports (BoP, current US$) of Low income in 2006 to that in 2010?
Your answer should be very brief. 0.55. What is the ratio of the Imports (BoP, current US$) in Cambodia in 2006 to that in 2010?
Ensure brevity in your answer.  0.86. What is the ratio of the Imports (BoP, current US$) in Kazakhstan in 2006 to that in 2010?
Offer a terse response. 0.74. What is the ratio of the Imports (BoP, current US$) of High income: nonOECD in 2006 to that in 2011?
Your answer should be compact. 0.61. What is the ratio of the Imports (BoP, current US$) in Low income in 2006 to that in 2011?
Your answer should be compact. 0.45. What is the ratio of the Imports (BoP, current US$) in Cambodia in 2006 to that in 2011?
Provide a succinct answer. 0.68. What is the ratio of the Imports (BoP, current US$) of Kazakhstan in 2006 to that in 2011?
Provide a short and direct response. 0.64. What is the ratio of the Imports (BoP, current US$) in High income: nonOECD in 2007 to that in 2008?
Your answer should be very brief. 0.85. What is the ratio of the Imports (BoP, current US$) in Low income in 2007 to that in 2008?
Provide a succinct answer. 0.77. What is the ratio of the Imports (BoP, current US$) of Cambodia in 2007 to that in 2008?
Offer a very short reply. 0.89. What is the ratio of the Imports (BoP, current US$) in Kazakhstan in 2007 to that in 2008?
Provide a succinct answer. 0.91. What is the ratio of the Imports (BoP, current US$) of High income: nonOECD in 2007 to that in 2009?
Ensure brevity in your answer.  1.07. What is the ratio of the Imports (BoP, current US$) of Low income in 2007 to that in 2009?
Provide a succinct answer. 0.83. What is the ratio of the Imports (BoP, current US$) of Cambodia in 2007 to that in 2009?
Give a very brief answer. 0.98. What is the ratio of the Imports (BoP, current US$) in Kazakhstan in 2007 to that in 2009?
Provide a short and direct response. 1.15. What is the ratio of the Imports (BoP, current US$) of High income: nonOECD in 2007 to that in 2010?
Offer a terse response. 0.86. What is the ratio of the Imports (BoP, current US$) in Low income in 2007 to that in 2010?
Offer a terse response. 0.68. What is the ratio of the Imports (BoP, current US$) of Cambodia in 2007 to that in 2010?
Offer a very short reply. 0.82. What is the ratio of the Imports (BoP, current US$) of Kazakhstan in 2007 to that in 2010?
Your answer should be compact. 1.02. What is the ratio of the Imports (BoP, current US$) in High income: nonOECD in 2007 to that in 2011?
Provide a short and direct response. 0.73. What is the ratio of the Imports (BoP, current US$) of Low income in 2007 to that in 2011?
Offer a terse response. 0.55. What is the ratio of the Imports (BoP, current US$) in Cambodia in 2007 to that in 2011?
Provide a short and direct response. 0.65. What is the ratio of the Imports (BoP, current US$) of Kazakhstan in 2007 to that in 2011?
Keep it short and to the point. 0.88. What is the ratio of the Imports (BoP, current US$) of High income: nonOECD in 2008 to that in 2009?
Keep it short and to the point. 1.26. What is the ratio of the Imports (BoP, current US$) of Low income in 2008 to that in 2009?
Your answer should be compact. 1.07. What is the ratio of the Imports (BoP, current US$) in Cambodia in 2008 to that in 2009?
Offer a terse response. 1.1. What is the ratio of the Imports (BoP, current US$) in Kazakhstan in 2008 to that in 2009?
Your response must be concise. 1.27. What is the ratio of the Imports (BoP, current US$) of High income: nonOECD in 2008 to that in 2010?
Ensure brevity in your answer.  1.02. What is the ratio of the Imports (BoP, current US$) of Low income in 2008 to that in 2010?
Provide a short and direct response. 0.88. What is the ratio of the Imports (BoP, current US$) in Cambodia in 2008 to that in 2010?
Give a very brief answer. 0.92. What is the ratio of the Imports (BoP, current US$) of Kazakhstan in 2008 to that in 2010?
Give a very brief answer. 1.12. What is the ratio of the Imports (BoP, current US$) of High income: nonOECD in 2008 to that in 2011?
Your answer should be very brief. 0.86. What is the ratio of the Imports (BoP, current US$) of Low income in 2008 to that in 2011?
Provide a succinct answer. 0.72. What is the ratio of the Imports (BoP, current US$) in Cambodia in 2008 to that in 2011?
Provide a short and direct response. 0.72. What is the ratio of the Imports (BoP, current US$) in Kazakhstan in 2008 to that in 2011?
Provide a short and direct response. 0.97. What is the ratio of the Imports (BoP, current US$) in High income: nonOECD in 2009 to that in 2010?
Offer a terse response. 0.81. What is the ratio of the Imports (BoP, current US$) of Low income in 2009 to that in 2010?
Your answer should be very brief. 0.82. What is the ratio of the Imports (BoP, current US$) in Cambodia in 2009 to that in 2010?
Offer a terse response. 0.84. What is the ratio of the Imports (BoP, current US$) of Kazakhstan in 2009 to that in 2010?
Provide a short and direct response. 0.88. What is the ratio of the Imports (BoP, current US$) of High income: nonOECD in 2009 to that in 2011?
Offer a very short reply. 0.68. What is the ratio of the Imports (BoP, current US$) of Low income in 2009 to that in 2011?
Your answer should be compact. 0.67. What is the ratio of the Imports (BoP, current US$) in Cambodia in 2009 to that in 2011?
Give a very brief answer. 0.66. What is the ratio of the Imports (BoP, current US$) in Kazakhstan in 2009 to that in 2011?
Give a very brief answer. 0.76. What is the ratio of the Imports (BoP, current US$) of High income: nonOECD in 2010 to that in 2011?
Keep it short and to the point. 0.84. What is the ratio of the Imports (BoP, current US$) in Low income in 2010 to that in 2011?
Your answer should be compact. 0.82. What is the ratio of the Imports (BoP, current US$) of Cambodia in 2010 to that in 2011?
Give a very brief answer. 0.78. What is the ratio of the Imports (BoP, current US$) of Kazakhstan in 2010 to that in 2011?
Your answer should be compact. 0.86. What is the difference between the highest and the second highest Imports (BoP, current US$) of High income: nonOECD?
Offer a very short reply. 3.88e+11. What is the difference between the highest and the second highest Imports (BoP, current US$) in Low income?
Your response must be concise. 2.55e+1. What is the difference between the highest and the second highest Imports (BoP, current US$) of Cambodia?
Provide a succinct answer. 1.78e+09. What is the difference between the highest and the second highest Imports (BoP, current US$) of Kazakhstan?
Your response must be concise. 1.75e+09. What is the difference between the highest and the lowest Imports (BoP, current US$) in High income: nonOECD?
Your answer should be very brief. 1.29e+12. What is the difference between the highest and the lowest Imports (BoP, current US$) in Low income?
Provide a succinct answer. 8.42e+1. What is the difference between the highest and the lowest Imports (BoP, current US$) in Cambodia?
Provide a short and direct response. 3.68e+09. What is the difference between the highest and the lowest Imports (BoP, current US$) of Kazakhstan?
Make the answer very short. 2.59e+1. 